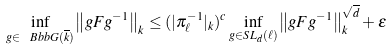<formula> <loc_0><loc_0><loc_500><loc_500>\inf _ { g \in \ B b b { G } ( \overline { k } ) } \left \| g F g ^ { - 1 } \right \| _ { k } \leq ( | \pi _ { \ell } ^ { - 1 } | _ { k } ) ^ { c } \inf _ { g \in S L _ { d } ( \ell ) } \left \| g F g ^ { - 1 } \right \| _ { k } ^ { \sqrt { d } } + \varepsilon</formula> 